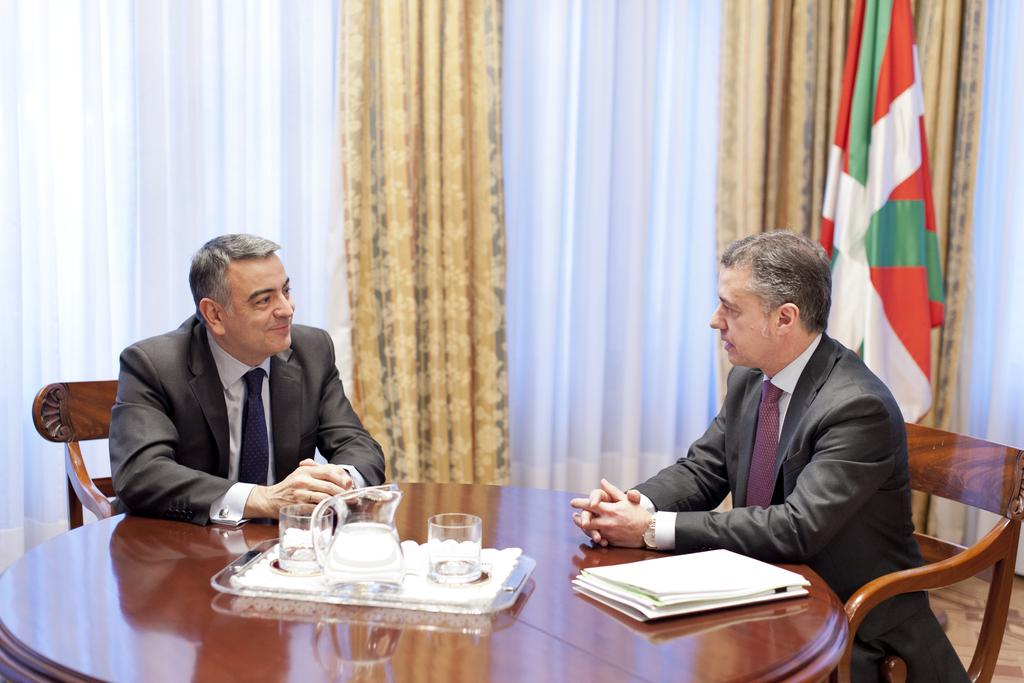How many people are in the image? There are two men in the image. What are the men doing in the image? The men are sitting on chairs. What type of cake is being served to the men in the image? There is no cake present in the image; the men are simply sitting on chairs. 